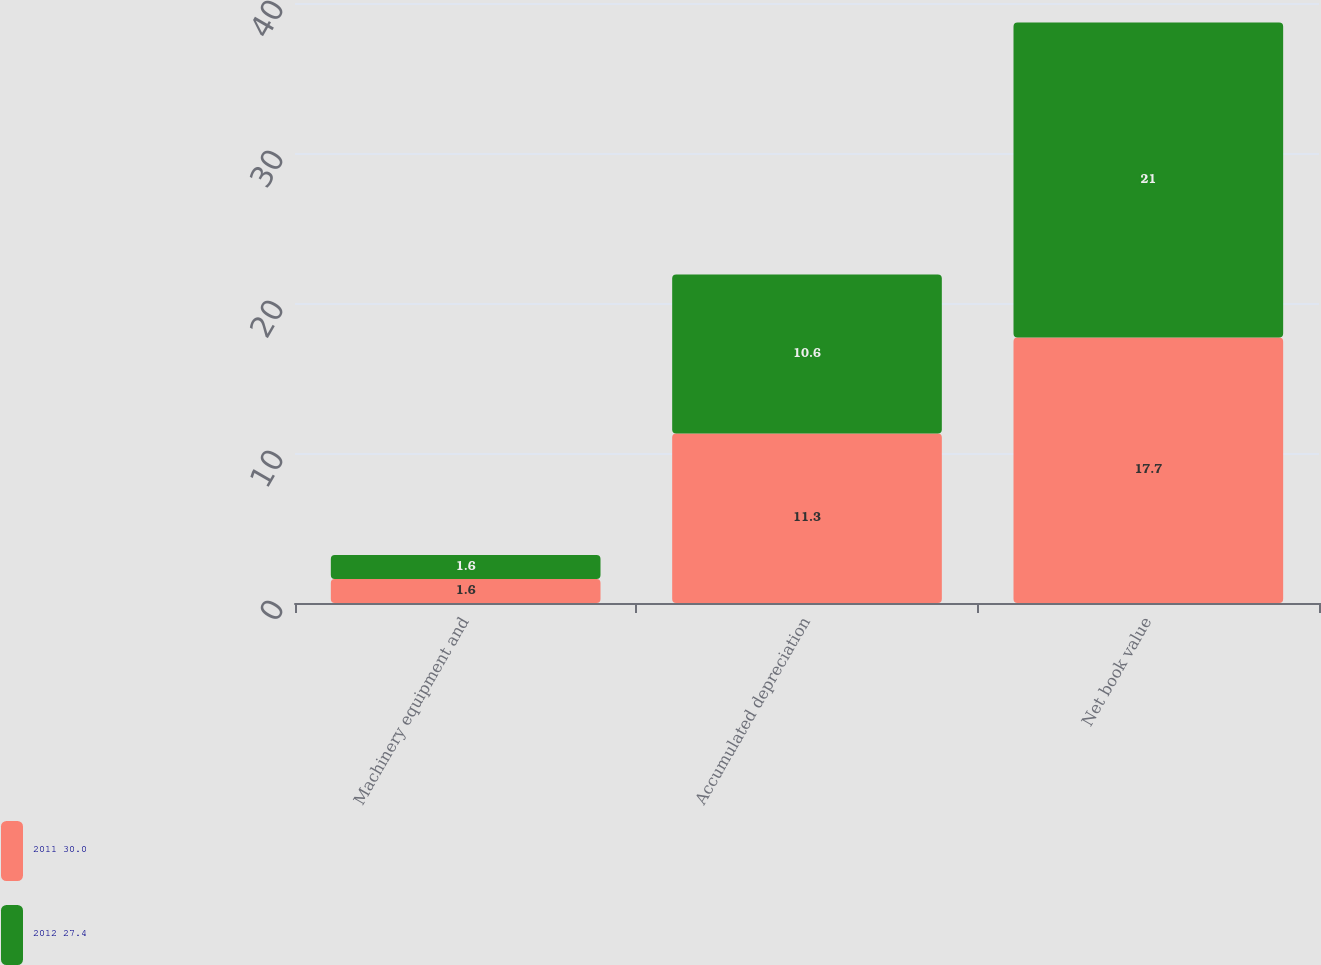<chart> <loc_0><loc_0><loc_500><loc_500><stacked_bar_chart><ecel><fcel>Machinery equipment and<fcel>Accumulated depreciation<fcel>Net book value<nl><fcel>2011 30.0<fcel>1.6<fcel>11.3<fcel>17.7<nl><fcel>2012 27.4<fcel>1.6<fcel>10.6<fcel>21<nl></chart> 